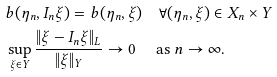Convert formula to latex. <formula><loc_0><loc_0><loc_500><loc_500>& b ( \eta _ { n } , I _ { n } \xi ) = b ( \eta _ { n } , \xi ) \quad \forall ( \eta _ { n } , \xi ) \in X _ { n } \times Y \\ & \sup _ { \xi \in Y } \frac { \| \xi - I _ { n } \xi \| _ { L } } { \| \xi \| _ { Y } } \rightarrow 0 \quad \text { as } n \rightarrow \infty .</formula> 